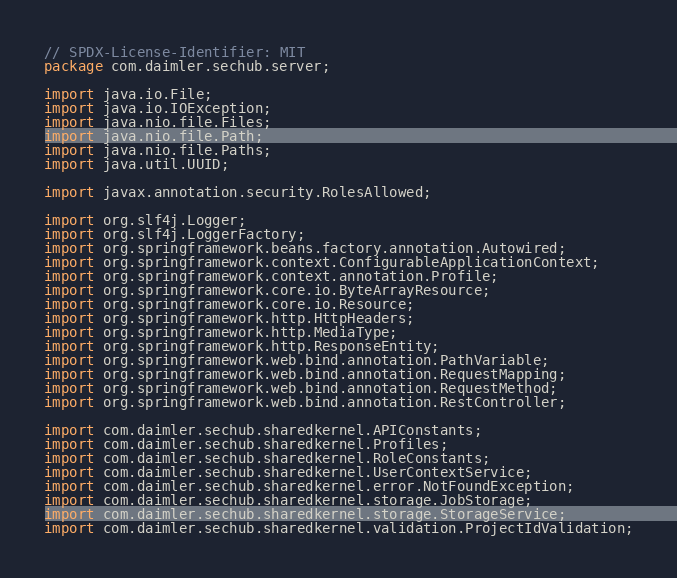Convert code to text. <code><loc_0><loc_0><loc_500><loc_500><_Java_>// SPDX-License-Identifier: MIT
package com.daimler.sechub.server;

import java.io.File;
import java.io.IOException;
import java.nio.file.Files;
import java.nio.file.Path;
import java.nio.file.Paths;
import java.util.UUID;

import javax.annotation.security.RolesAllowed;

import org.slf4j.Logger;
import org.slf4j.LoggerFactory;
import org.springframework.beans.factory.annotation.Autowired;
import org.springframework.context.ConfigurableApplicationContext;
import org.springframework.context.annotation.Profile;
import org.springframework.core.io.ByteArrayResource;
import org.springframework.core.io.Resource;
import org.springframework.http.HttpHeaders;
import org.springframework.http.MediaType;
import org.springframework.http.ResponseEntity;
import org.springframework.web.bind.annotation.PathVariable;
import org.springframework.web.bind.annotation.RequestMapping;
import org.springframework.web.bind.annotation.RequestMethod;
import org.springframework.web.bind.annotation.RestController;

import com.daimler.sechub.sharedkernel.APIConstants;
import com.daimler.sechub.sharedkernel.Profiles;
import com.daimler.sechub.sharedkernel.RoleConstants;
import com.daimler.sechub.sharedkernel.UserContextService;
import com.daimler.sechub.sharedkernel.error.NotFoundException;
import com.daimler.sechub.sharedkernel.storage.JobStorage;
import com.daimler.sechub.sharedkernel.storage.StorageService;
import com.daimler.sechub.sharedkernel.validation.ProjectIdValidation;</code> 